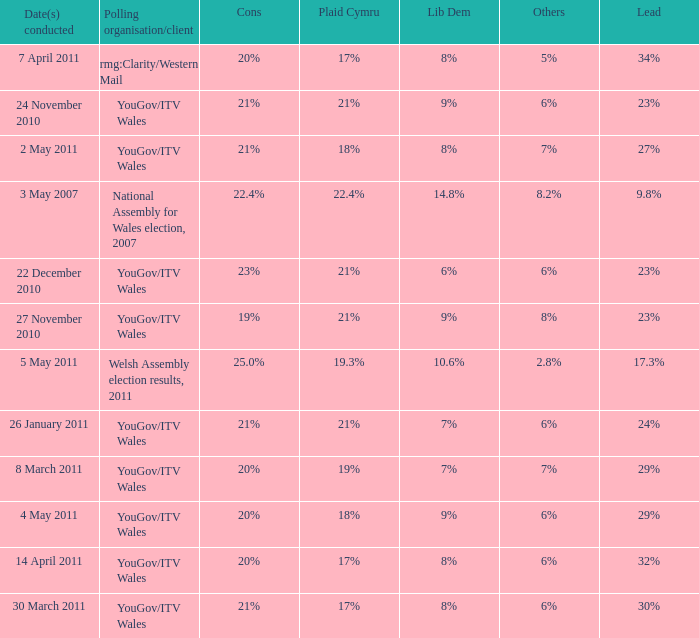Can you parse all the data within this table? {'header': ['Date(s) conducted', 'Polling organisation/client', 'Cons', 'Plaid Cymru', 'Lib Dem', 'Others', 'Lead'], 'rows': [['7 April 2011', 'rmg:Clarity/Western Mail', '20%', '17%', '8%', '5%', '34%'], ['24 November 2010', 'YouGov/ITV Wales', '21%', '21%', '9%', '6%', '23%'], ['2 May 2011', 'YouGov/ITV Wales', '21%', '18%', '8%', '7%', '27%'], ['3 May 2007', 'National Assembly for Wales election, 2007', '22.4%', '22.4%', '14.8%', '8.2%', '9.8%'], ['22 December 2010', 'YouGov/ITV Wales', '23%', '21%', '6%', '6%', '23%'], ['27 November 2010', 'YouGov/ITV Wales', '19%', '21%', '9%', '8%', '23%'], ['5 May 2011', 'Welsh Assembly election results, 2011', '25.0%', '19.3%', '10.6%', '2.8%', '17.3%'], ['26 January 2011', 'YouGov/ITV Wales', '21%', '21%', '7%', '6%', '24%'], ['8 March 2011', 'YouGov/ITV Wales', '20%', '19%', '7%', '7%', '29%'], ['4 May 2011', 'YouGov/ITV Wales', '20%', '18%', '9%', '6%', '29%'], ['14 April 2011', 'YouGov/ITV Wales', '20%', '17%', '8%', '6%', '32%'], ['30 March 2011', 'YouGov/ITV Wales', '21%', '17%', '8%', '6%', '30%']]} Tell me the dates conducted for plaid cymru of 19% 8 March 2011. 